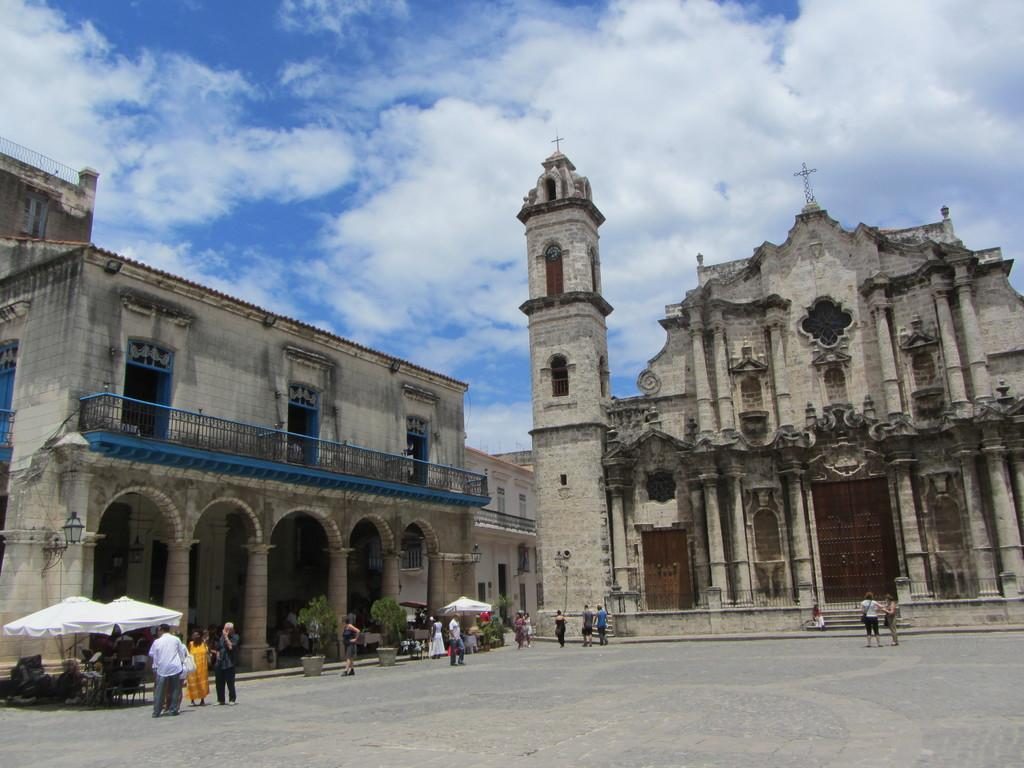What type of building is the main subject in the image? There is a big church in the image. Are there any other buildings nearby? Yes, there is a building beside the church. What is happening around the church? Many people are visiting the church. What is the landscape like in front of the church? There is a huge open land in front of the church. How many passengers are inside the church in the image? There are no passengers mentioned or visible in the image, as it features a church and its surroundings. 